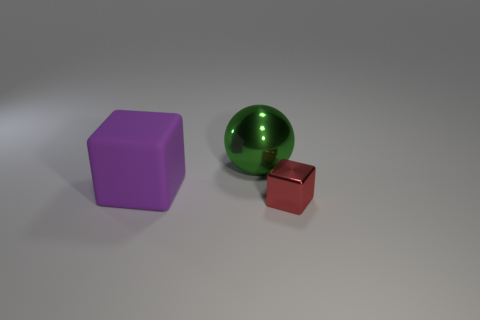What number of metallic objects are large purple objects or big green things?
Offer a very short reply. 1. There is a thing that is the same size as the metallic sphere; what material is it?
Your response must be concise. Rubber. How many other objects are there of the same material as the green sphere?
Offer a very short reply. 1. Is the number of large shiny objects that are behind the green shiny thing less than the number of purple objects?
Provide a short and direct response. Yes. Is the purple thing the same shape as the tiny object?
Keep it short and to the point. Yes. There is a thing that is behind the thing that is to the left of the metal object on the left side of the red block; what is its size?
Provide a succinct answer. Large. What is the material of the red object that is the same shape as the large purple rubber thing?
Offer a very short reply. Metal. Are there any other things that are the same size as the red block?
Your answer should be compact. No. There is a block that is to the left of the object to the right of the large metallic ball; how big is it?
Ensure brevity in your answer.  Large. What color is the shiny sphere?
Provide a short and direct response. Green. 